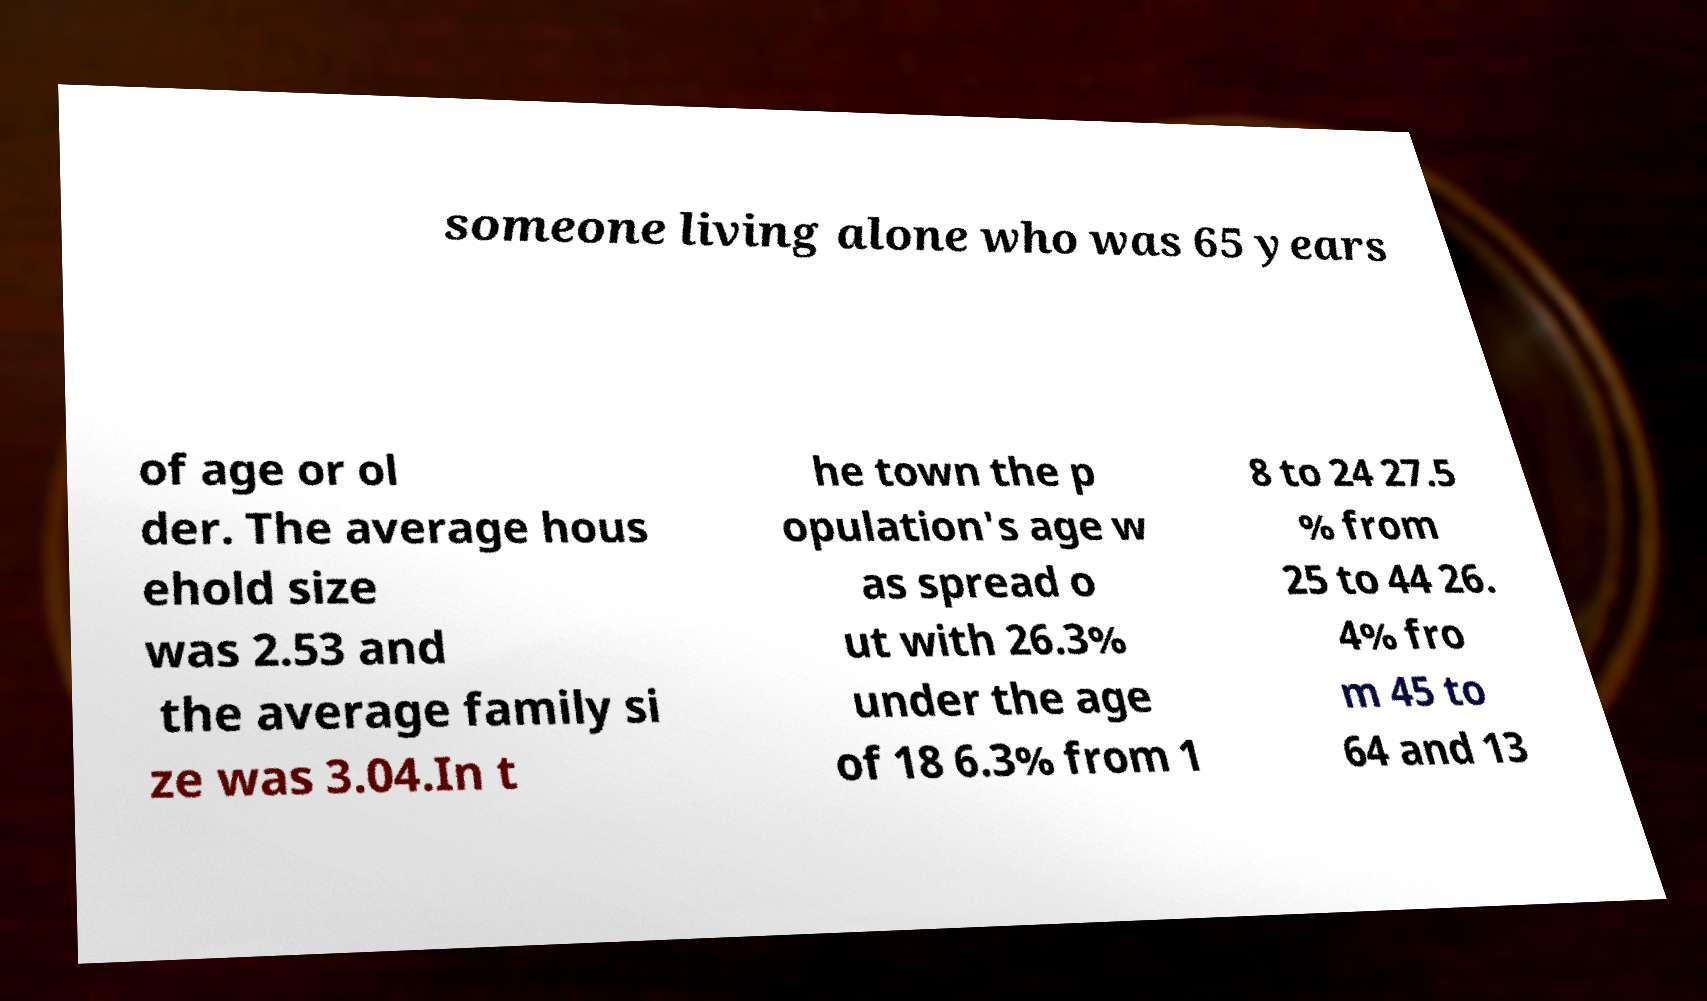Please identify and transcribe the text found in this image. someone living alone who was 65 years of age or ol der. The average hous ehold size was 2.53 and the average family si ze was 3.04.In t he town the p opulation's age w as spread o ut with 26.3% under the age of 18 6.3% from 1 8 to 24 27.5 % from 25 to 44 26. 4% fro m 45 to 64 and 13 